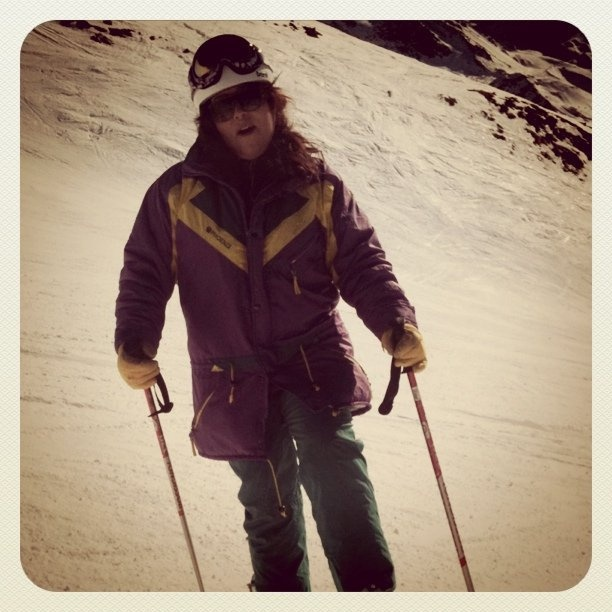Describe the objects in this image and their specific colors. I can see people in ivory, black, maroon, brown, and gray tones in this image. 